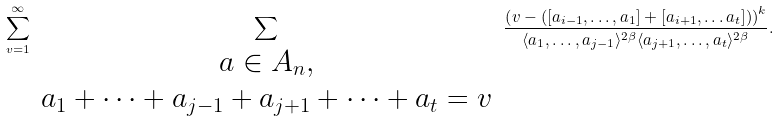<formula> <loc_0><loc_0><loc_500><loc_500>\sum _ { v = 1 } ^ { \infty } \sum _ { \begin{array} { c } a \in A _ { n } , \\ a _ { 1 } + \dots + a _ { j - 1 } + a _ { j + 1 } + \dots + a _ { t } = v \end{array} } \frac { \left ( v - \left ( [ a _ { i - 1 } , \dots , a _ { 1 } ] + [ a _ { i + 1 } , \dots a _ { t } ] \right ) \right ) ^ { k } } { \langle a _ { 1 } , \dots , a _ { j - 1 } \rangle ^ { 2 \beta } \langle a _ { j + 1 } , \dots , a _ { t } \rangle ^ { 2 \beta } } .</formula> 